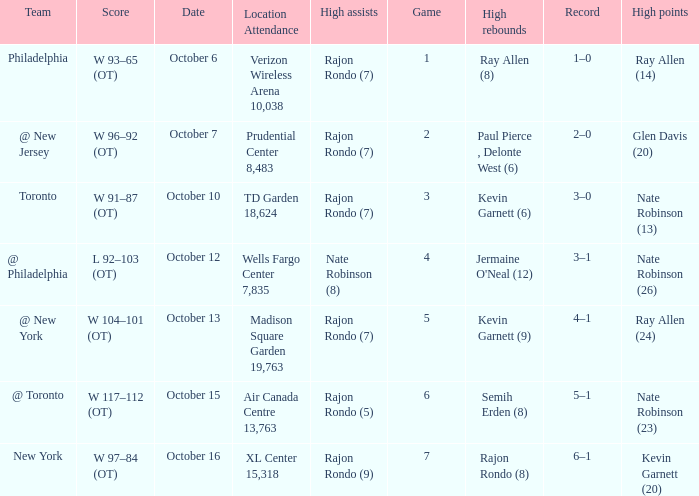Could you parse the entire table? {'header': ['Team', 'Score', 'Date', 'Location Attendance', 'High assists', 'Game', 'High rebounds', 'Record', 'High points'], 'rows': [['Philadelphia', 'W 93–65 (OT)', 'October 6', 'Verizon Wireless Arena 10,038', 'Rajon Rondo (7)', '1', 'Ray Allen (8)', '1–0', 'Ray Allen (14)'], ['@ New Jersey', 'W 96–92 (OT)', 'October 7', 'Prudential Center 8,483', 'Rajon Rondo (7)', '2', 'Paul Pierce , Delonte West (6)', '2–0', 'Glen Davis (20)'], ['Toronto', 'W 91–87 (OT)', 'October 10', 'TD Garden 18,624', 'Rajon Rondo (7)', '3', 'Kevin Garnett (6)', '3–0', 'Nate Robinson (13)'], ['@ Philadelphia', 'L 92–103 (OT)', 'October 12', 'Wells Fargo Center 7,835', 'Nate Robinson (8)', '4', "Jermaine O'Neal (12)", '3–1', 'Nate Robinson (26)'], ['@ New York', 'W 104–101 (OT)', 'October 13', 'Madison Square Garden 19,763', 'Rajon Rondo (7)', '5', 'Kevin Garnett (9)', '4–1', 'Ray Allen (24)'], ['@ Toronto', 'W 117–112 (OT)', 'October 15', 'Air Canada Centre 13,763', 'Rajon Rondo (5)', '6', 'Semih Erden (8)', '5–1', 'Nate Robinson (23)'], ['New York', 'W 97–84 (OT)', 'October 16', 'XL Center 15,318', 'Rajon Rondo (9)', '7', 'Rajon Rondo (8)', '6–1', 'Kevin Garnett (20)']]} Who had the most assists and how many did they have on October 7?  Rajon Rondo (7). 